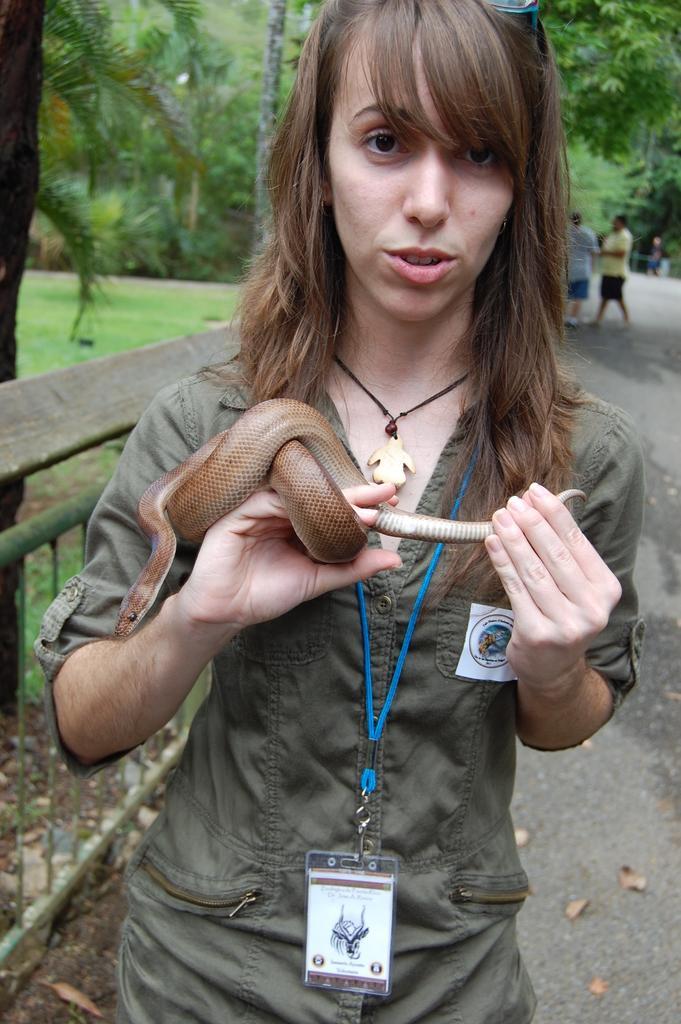In one or two sentences, can you explain what this image depicts? In this image, we can see a person holding a snake with her hands. This person is wearing clothes and ID card. There are two persons standing in the top right of the image. In the background of the image, there are some trees. 